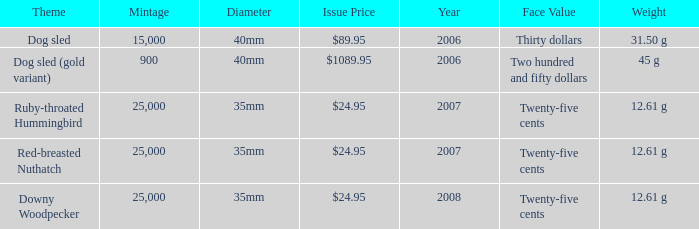What is the MIntage after 2006 of the Ruby-Throated Hummingbird Theme coin? 25000.0. 